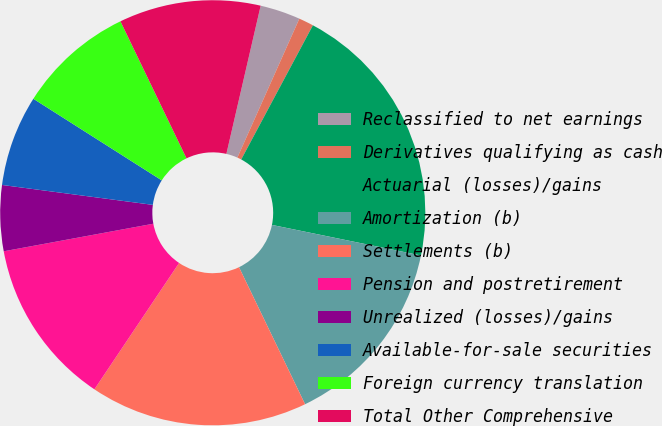<chart> <loc_0><loc_0><loc_500><loc_500><pie_chart><fcel>Reclassified to net earnings<fcel>Derivatives qualifying as cash<fcel>Actuarial (losses)/gains<fcel>Amortization (b)<fcel>Settlements (b)<fcel>Pension and postretirement<fcel>Unrealized (losses)/gains<fcel>Available-for-sale securities<fcel>Foreign currency translation<fcel>Total Other Comprehensive<nl><fcel>3.06%<fcel>1.13%<fcel>20.41%<fcel>14.63%<fcel>16.55%<fcel>12.7%<fcel>4.99%<fcel>6.92%<fcel>8.84%<fcel>10.77%<nl></chart> 